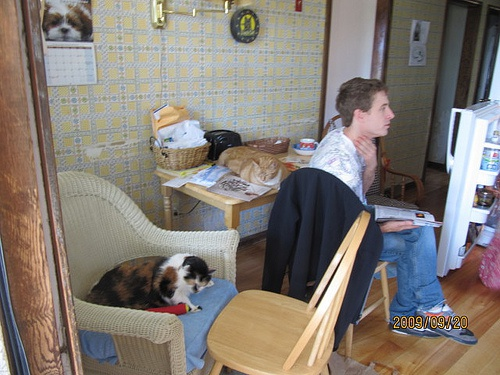Describe the objects in this image and their specific colors. I can see chair in gray, darkgray, and black tones, people in gray, lavender, and blue tones, chair in gray and tan tones, dining table in gray, darkgray, and tan tones, and refrigerator in gray, white, lightblue, and darkgray tones in this image. 